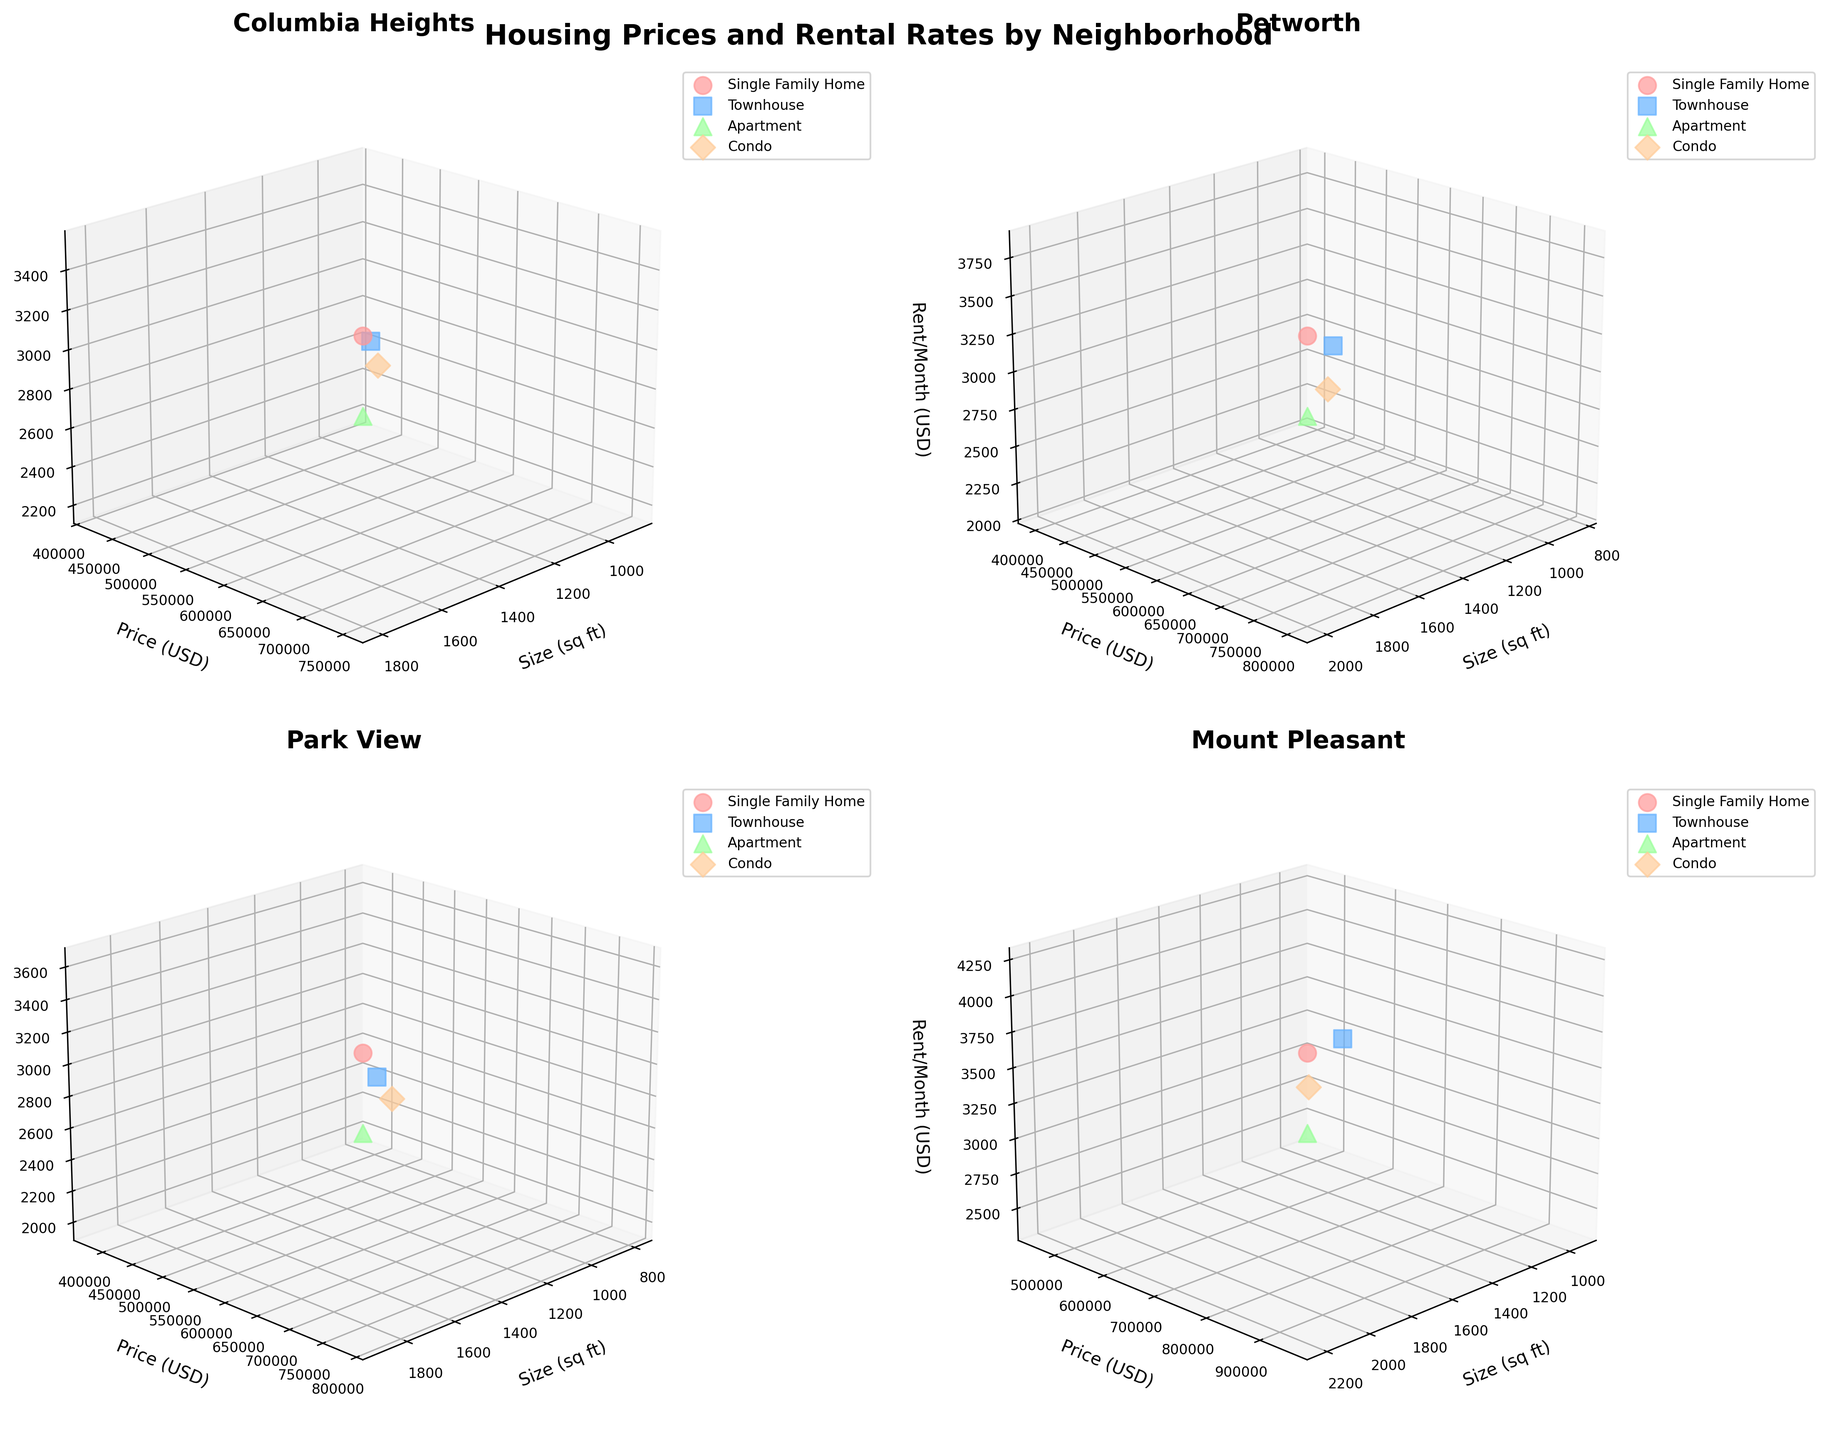What's the title of the figure? The title of the figure is displayed at the top and provides a summary of what the plots represent. In this case, it is "Housing Prices and Rental Rates by Neighborhood".
Answer: Housing Prices and Rental Rates by Neighborhood Which neighborhood shows the highest property price for a Single Family Home? The subplot title indicating the neighborhood can be checked, followed by identifying the data point for Single Family Home with the highest y-axis (Price in USD). This occurs in Mount Pleasant.
Answer: Mount Pleasant In which neighborhood is there the smallest sized Apartment and what is its rental rate per month? By checking the x-axis (Size_sqft) and identifying the smallest value for Apartments in each subplot, you find that Park View has the smallest Apartment size of 800 sqft. The rental rate per month is then found on the z-axis.
Answer: Park View, $2000 Compare the rent per month for Townhouses in Columbia Heights and Petworth. Which one is higher? The markers for Townhouses in both Columbia Heights and Petworth subplots can be compared. The z-axis (RentPerMonth_USD) for Townhouses indicates that Petworth has a higher rent per month ($3400) compared to Columbia Heights ($3200).
Answer: Petworth Which property type consistently shows higher rental rates in all neighborhoods? To answer this, check the subplot of each neighborhood and compare the z-axis values for each property type (Single Family Home, Townhouse, Apartment, Condo). Single Family Homes consistently show higher rental rates.
Answer: Single Family Home What is the average price of Condos in Mount Pleasant? Identify the y-axis (Price_USD) values for Condos in the Mount Pleasant subplot. There is one data point with a price of $600,000. The average is calculated by dividing the sum ($600,000) by 1.
Answer: $600,000 How does the size (sq ft) of Single Family Homes in Park View compare to those in Petworth? Check the x-axis (Size_sqft) in both the Park View and Petworth subplots. Single Family Homes in Park View are 1900 sq ft, whereas in Petworth they are 2000 sq ft.
Answer: Smaller in Park View Which neighborhood has the highest rental rates for Apartments? Focus on the subplot for each neighborhood and identify the highest z-axis value for Apartments. Mount Pleasant has the highest rental rates for Apartments at $2400 per month.
Answer: Mount Pleasant What is the range of property sizes for Townhouses in all neighborhoods? Review all subplots and identify the min and max x-axis (Size_sqft) values for Townhouses. Sizes range from 1400 sq ft (Park View) to 1700 sq ft (Mount Pleasant).
Answer: 1400-1700 sq ft 